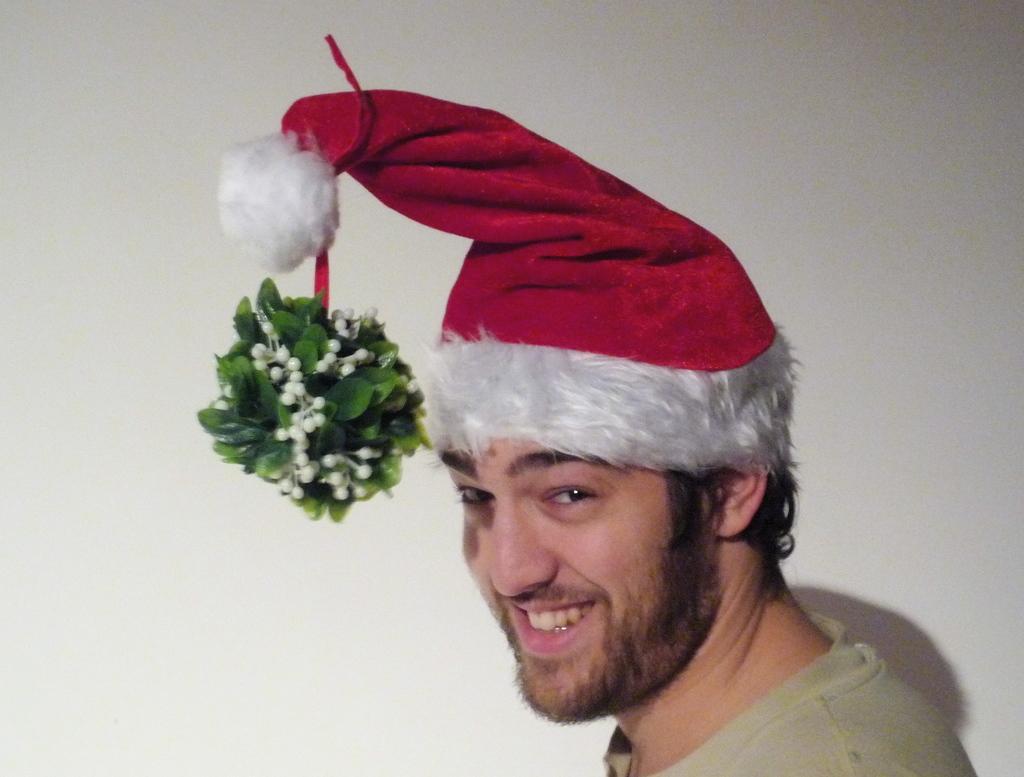Please provide a concise description of this image. On the right side, there is a person in a gray color T-shirt, wearing a red color cap and smiling. On the left side, there are green color leaves and white colored flowers connected to the tail of this cap. And the background is white in color. 